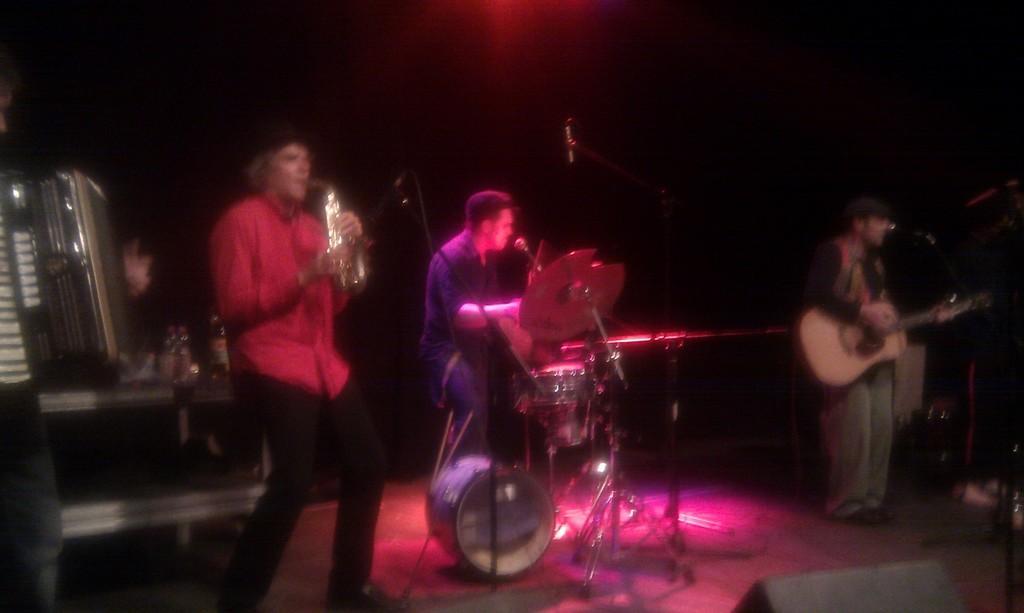How would you summarize this image in a sentence or two? This is a blurred picture where we have three people playing different musical instruments and the people are in red, blue and black color shirts and also the background is black and there is some focus light of pink and red color on them. 